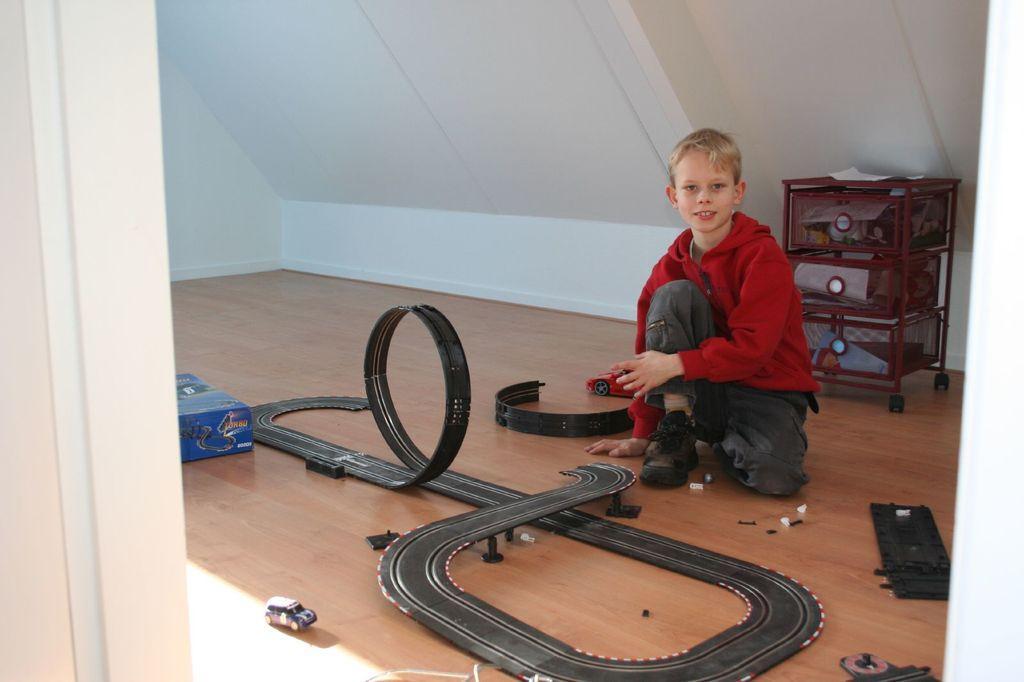Can you describe this image briefly? In this picture, we can see a boy in the red hood is on the path. In front of a boy there are some toys and a box. Behind the boy there is an object and a white wall. 